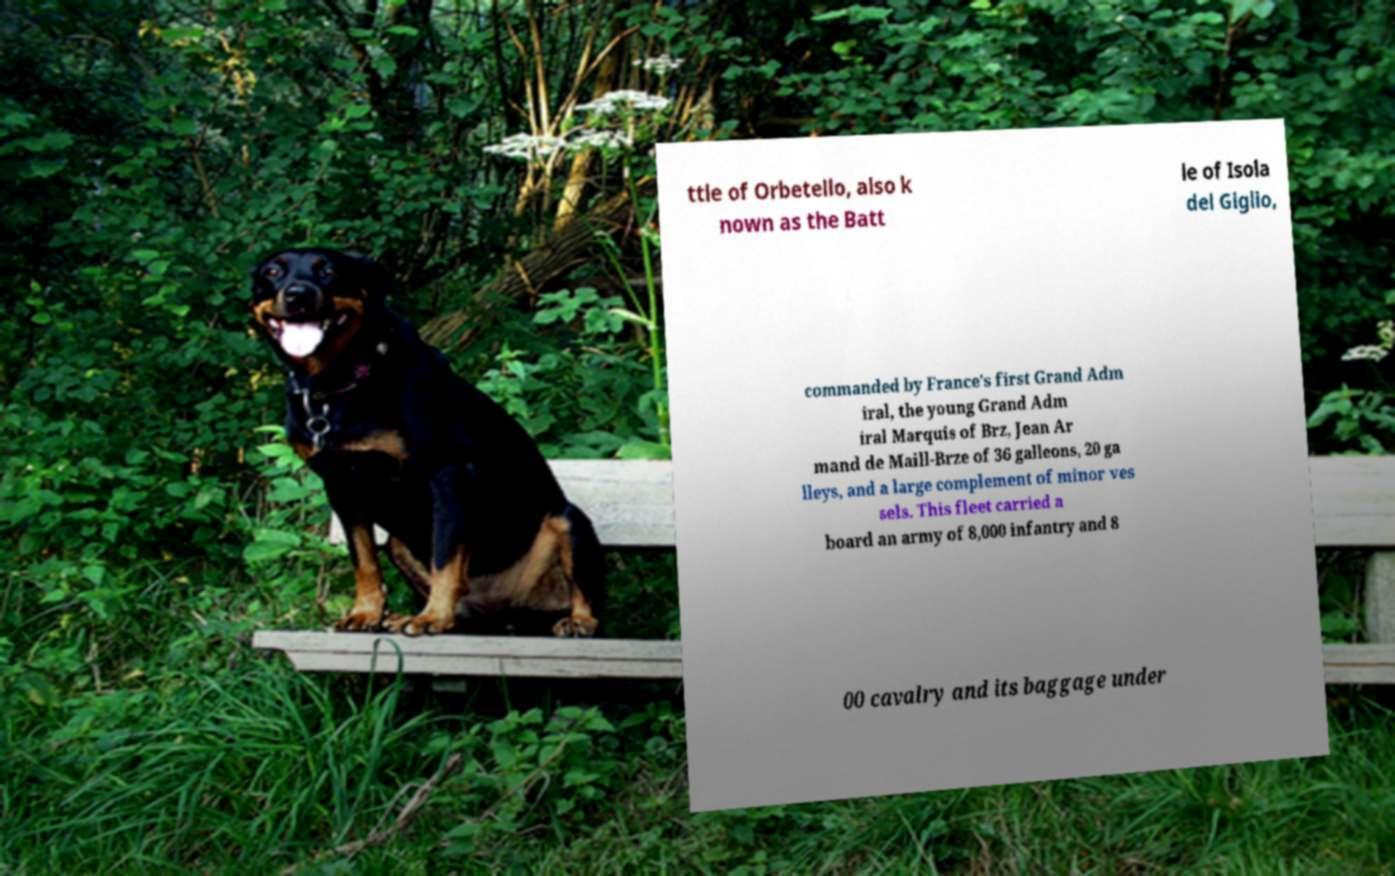I need the written content from this picture converted into text. Can you do that? ttle of Orbetello, also k nown as the Batt le of Isola del Giglio, commanded by France's first Grand Adm iral, the young Grand Adm iral Marquis of Brz, Jean Ar mand de Maill-Brze of 36 galleons, 20 ga lleys, and a large complement of minor ves sels. This fleet carried a board an army of 8,000 infantry and 8 00 cavalry and its baggage under 